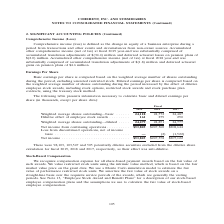According to Coherent's financial document, How was basic earnings per share computed? based on the weighted average number of shares outstanding during the period, excluding unvested restricted stock. The document states: "Basic earnings per share is computed based on the weighted average number of shares outstanding during the period, excluding unvested restricted stock..." Also, How was diluted earnings per share computed? based on the weighted average number of shares outstanding during the period increased by the effect of dilutive employee stock awards, including stock options, restricted stock awards and stock purchase plan contracts, using the treasury stock method. The document states: "ted stock. Diluted earnings per share is computed based on the weighted average number of shares outstanding during the period increased by the effect..." Also, In which years was earnings per share provided in the table? The document contains multiple relevant values: 2019, 2018, 2017. From the document: "Fiscal 2019 2018 2017 Fiscal 2019 2018 2017 Fiscal 2019 2018 2017..." Additionally, In which year was the Dilutive effect of employee stock awards largest? According to the financial document, 2017. The relevant text states: "Fiscal 2019 2018 2017..." Also, can you calculate: What was the change in Dilutive effect of employee stock awards in 2019 from 2018? Based on the calculation: 161-279, the result is -118 (in thousands). This is based on the information: "24,487 Dilutive effect of employee stock awards . 161 279 290 87 Dilutive effect of employee stock awards . 161 279 290..." The key data points involved are: 161, 279. Also, can you calculate: What was the percentage change in Dilutive effect of employee stock awards in 2019 from 2018? To answer this question, I need to perform calculations using the financial data. The calculation is: (161-279)/279, which equals -42.29 (percentage). This is based on the information: "24,487 Dilutive effect of employee stock awards . 161 279 290 87 Dilutive effect of employee stock awards . 161 279 290..." The key data points involved are: 161, 279. 